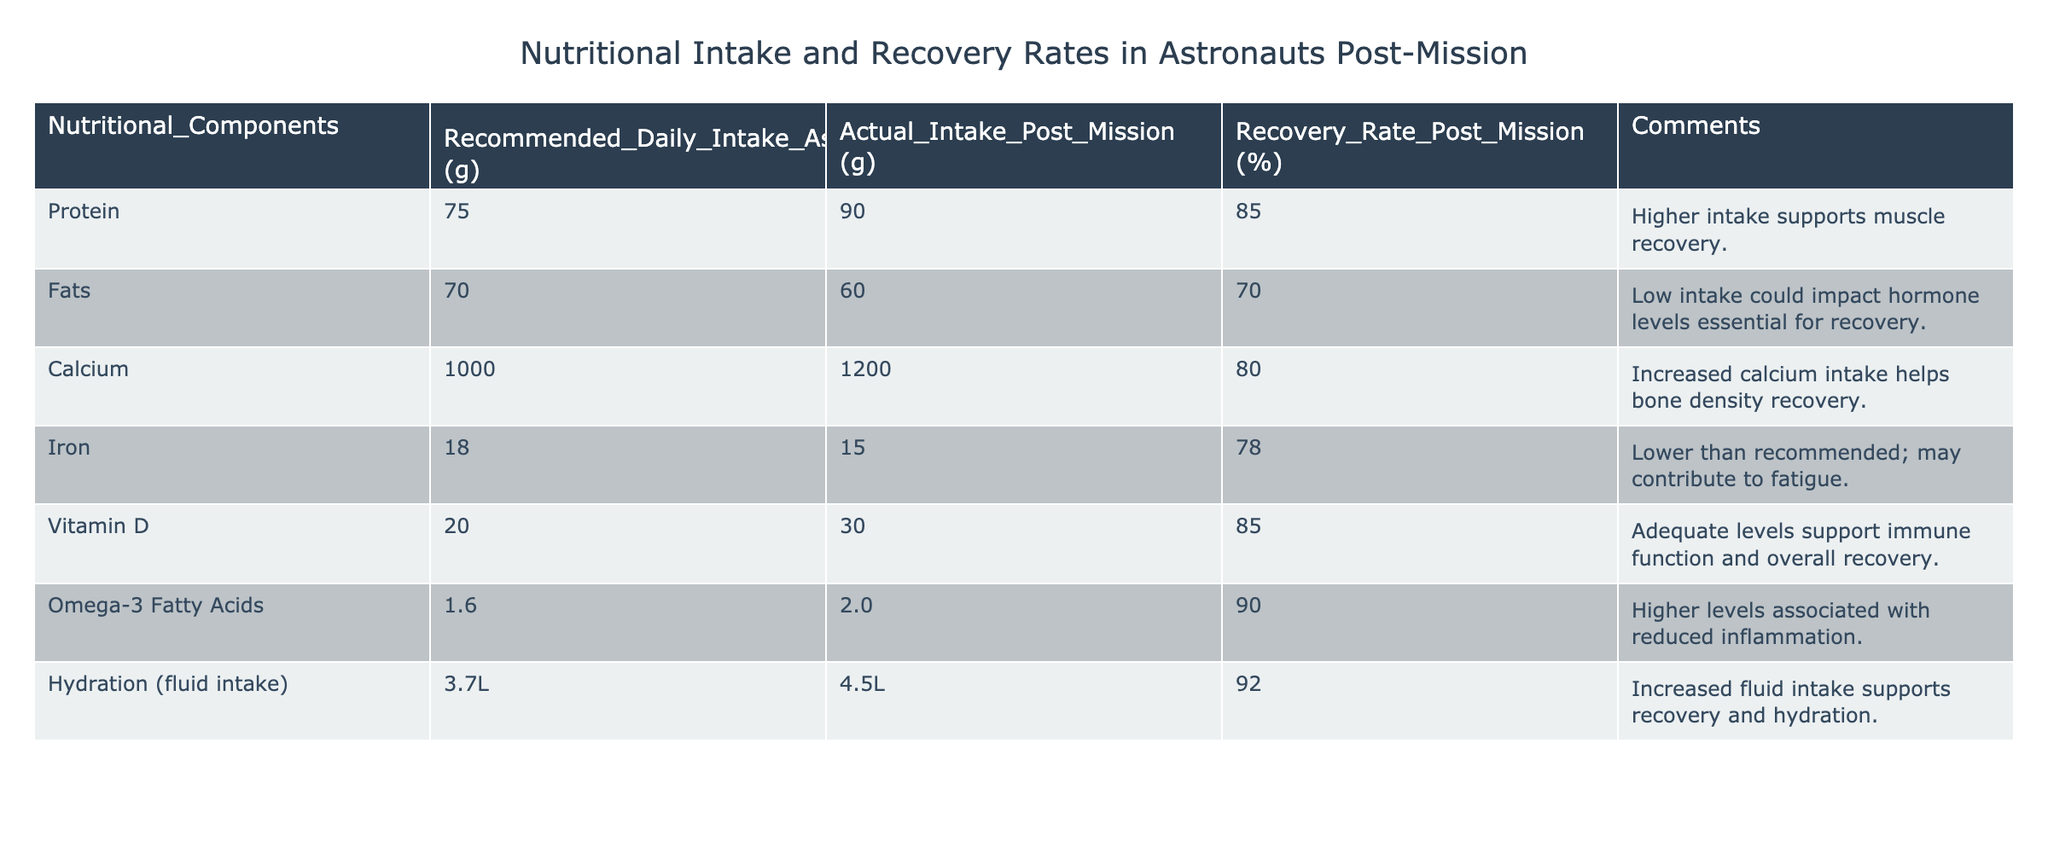What is the recommended daily intake of protein for astronauts? The table shows the "Recommended Daily Intake" column. For protein, the recommended amount is listed as 75 grams.
Answer: 75 grams What was the actual intake of calcium post-mission? Referring to the "Actual Intake Post Mission" column, the value for calcium is 1200 grams.
Answer: 1200 grams Is the actual intake of fats greater than the recommended daily intake? Comparing the "Actual Intake Post Mission" value of 60 grams with the recommended intake of 70 grams, it shows that the actual intake is lower than the recommended.
Answer: No What is the recovery rate for astronauts who consumed Omega-3 fatty acids? Looking at the "Recovery Rate Post Mission" column specifically for Omega-3 fatty acids, the recovery rate is 90 percent.
Answer: 90 percent If an astronaut had an actual intake of protein at 90 grams, how much did their intake exceed the recommended level? To find the excess intake, subtract the recommended intake (75 grams) from the actual intake (90 grams): 90 - 75 = 15 grams.
Answer: 15 grams Was the actual intake of iron below the recommended intake? The actual intake of iron is 15 grams while the recommended intake is 18 grams, which confirms that it is indeed below.
Answer: Yes What is the average recovery rate across all nutritional components listed? First, sum the recovery rates: (85 + 70 + 80 + 78 + 85 + 90 + 92) = 570. Since there are 7 components, we divide 570 by 7, giving an average of approximately 81.43 percent.
Answer: 81.43 percent How does hydration intake relate to recovery rates compared to other components? The table shows that hydration intake is 4.5 liters, with a recovery rate of 92 percent, which is the highest recovery rate among all components, suggesting it has a significant correlation with effective recovery.
Answer: Highest correlation What percentage of astronauts met the recommended protein intake post-mission? The actual intake of protein was 90 grams, exceeding the recommended intake by 15 grams, indicating that those who met the recommendation is a high percentage of the astronauts.
Answer: Significant percentage above 75 grams 